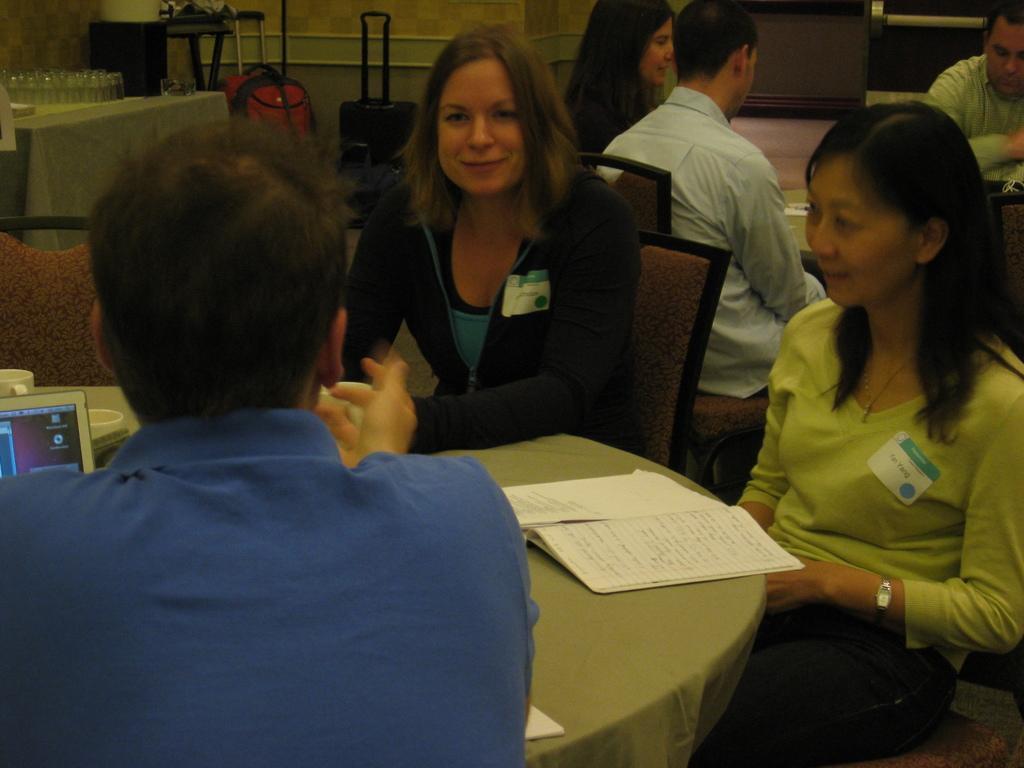Describe this image in one or two sentences. In this image, we can see people are sitting on the chairs. we can see tables are covered with clothes. On top of that there are few objects and cups are placed. In the background, we can see glass objects, luggage, wall, cloth, floor and few things. 